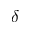<formula> <loc_0><loc_0><loc_500><loc_500>\delta</formula> 